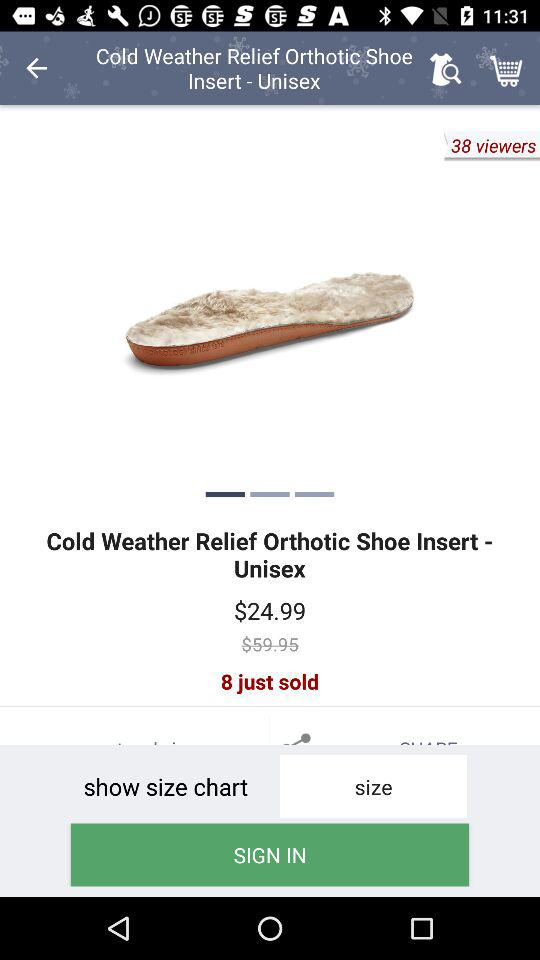How many products are sold? There are 8 products sold. 